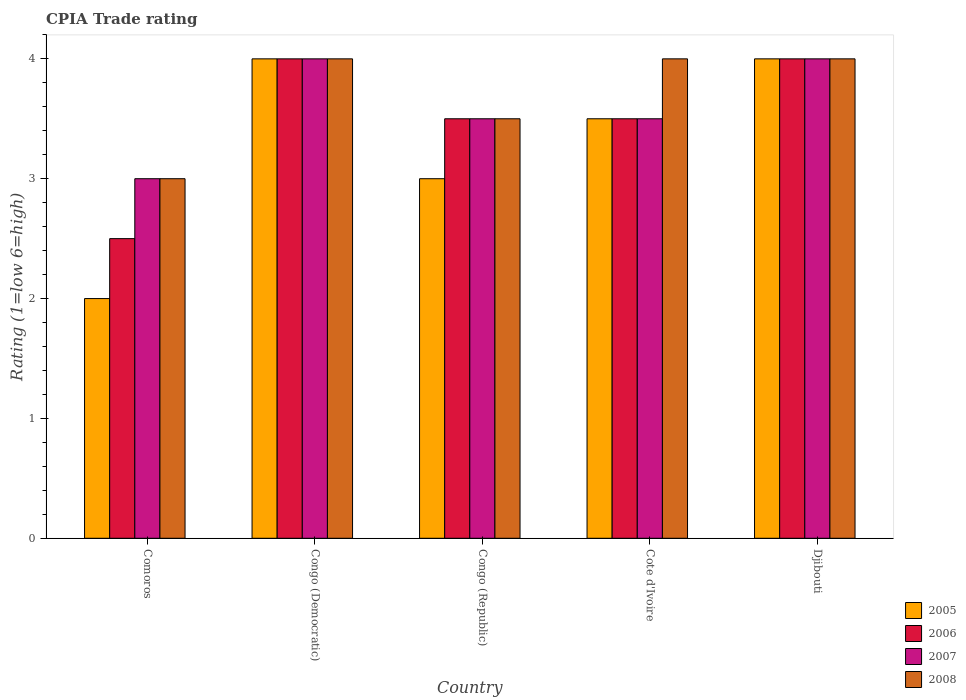Are the number of bars per tick equal to the number of legend labels?
Your answer should be very brief. Yes. What is the label of the 4th group of bars from the left?
Give a very brief answer. Cote d'Ivoire. In how many cases, is the number of bars for a given country not equal to the number of legend labels?
Your response must be concise. 0. In which country was the CPIA rating in 2007 maximum?
Keep it short and to the point. Congo (Democratic). In which country was the CPIA rating in 2006 minimum?
Your answer should be very brief. Comoros. What is the total CPIA rating in 2007 in the graph?
Offer a terse response. 18. What is the difference between the CPIA rating in 2007 in Comoros and that in Congo (Republic)?
Ensure brevity in your answer.  -0.5. What is the difference between the CPIA rating in 2008 in Djibouti and the CPIA rating in 2006 in Congo (Republic)?
Your answer should be very brief. 0.5. What is the ratio of the CPIA rating in 2007 in Comoros to that in Congo (Democratic)?
Ensure brevity in your answer.  0.75. Is the difference between the CPIA rating in 2005 in Congo (Democratic) and Cote d'Ivoire greater than the difference between the CPIA rating in 2008 in Congo (Democratic) and Cote d'Ivoire?
Your answer should be very brief. Yes. What is the difference between the highest and the second highest CPIA rating in 2005?
Ensure brevity in your answer.  -0.5. Is the sum of the CPIA rating in 2005 in Congo (Republic) and Djibouti greater than the maximum CPIA rating in 2006 across all countries?
Ensure brevity in your answer.  Yes. What does the 2nd bar from the right in Congo (Democratic) represents?
Provide a succinct answer. 2007. Is it the case that in every country, the sum of the CPIA rating in 2007 and CPIA rating in 2008 is greater than the CPIA rating in 2006?
Keep it short and to the point. Yes. How many bars are there?
Offer a terse response. 20. How many countries are there in the graph?
Offer a very short reply. 5. What is the difference between two consecutive major ticks on the Y-axis?
Make the answer very short. 1. Does the graph contain any zero values?
Make the answer very short. No. Does the graph contain grids?
Provide a succinct answer. No. How many legend labels are there?
Provide a short and direct response. 4. How are the legend labels stacked?
Offer a very short reply. Vertical. What is the title of the graph?
Ensure brevity in your answer.  CPIA Trade rating. Does "2000" appear as one of the legend labels in the graph?
Provide a short and direct response. No. What is the Rating (1=low 6=high) of 2005 in Comoros?
Offer a very short reply. 2. What is the Rating (1=low 6=high) in 2006 in Comoros?
Give a very brief answer. 2.5. What is the Rating (1=low 6=high) in 2005 in Congo (Democratic)?
Your answer should be very brief. 4. What is the Rating (1=low 6=high) in 2006 in Congo (Democratic)?
Provide a succinct answer. 4. What is the Rating (1=low 6=high) of 2007 in Congo (Democratic)?
Your answer should be very brief. 4. What is the Rating (1=low 6=high) in 2008 in Congo (Democratic)?
Keep it short and to the point. 4. What is the Rating (1=low 6=high) in 2006 in Congo (Republic)?
Keep it short and to the point. 3.5. What is the Rating (1=low 6=high) of 2007 in Congo (Republic)?
Offer a very short reply. 3.5. What is the Rating (1=low 6=high) of 2008 in Congo (Republic)?
Your answer should be very brief. 3.5. What is the Rating (1=low 6=high) in 2005 in Cote d'Ivoire?
Provide a succinct answer. 3.5. What is the Rating (1=low 6=high) in 2005 in Djibouti?
Your answer should be very brief. 4. What is the Rating (1=low 6=high) of 2007 in Djibouti?
Your answer should be very brief. 4. What is the Rating (1=low 6=high) of 2008 in Djibouti?
Provide a short and direct response. 4. Across all countries, what is the maximum Rating (1=low 6=high) in 2005?
Offer a very short reply. 4. Across all countries, what is the maximum Rating (1=low 6=high) in 2006?
Your answer should be compact. 4. Across all countries, what is the minimum Rating (1=low 6=high) of 2007?
Offer a very short reply. 3. What is the total Rating (1=low 6=high) in 2005 in the graph?
Offer a terse response. 16.5. What is the total Rating (1=low 6=high) in 2008 in the graph?
Keep it short and to the point. 18.5. What is the difference between the Rating (1=low 6=high) of 2005 in Comoros and that in Congo (Democratic)?
Provide a short and direct response. -2. What is the difference between the Rating (1=low 6=high) of 2006 in Comoros and that in Congo (Democratic)?
Ensure brevity in your answer.  -1.5. What is the difference between the Rating (1=low 6=high) in 2007 in Comoros and that in Congo (Democratic)?
Your response must be concise. -1. What is the difference between the Rating (1=low 6=high) of 2008 in Comoros and that in Congo (Democratic)?
Offer a very short reply. -1. What is the difference between the Rating (1=low 6=high) of 2005 in Comoros and that in Congo (Republic)?
Provide a short and direct response. -1. What is the difference between the Rating (1=low 6=high) of 2006 in Comoros and that in Congo (Republic)?
Your answer should be compact. -1. What is the difference between the Rating (1=low 6=high) in 2007 in Comoros and that in Congo (Republic)?
Ensure brevity in your answer.  -0.5. What is the difference between the Rating (1=low 6=high) of 2008 in Comoros and that in Congo (Republic)?
Provide a succinct answer. -0.5. What is the difference between the Rating (1=low 6=high) of 2005 in Comoros and that in Cote d'Ivoire?
Offer a terse response. -1.5. What is the difference between the Rating (1=low 6=high) in 2005 in Comoros and that in Djibouti?
Provide a succinct answer. -2. What is the difference between the Rating (1=low 6=high) in 2008 in Congo (Democratic) and that in Congo (Republic)?
Your answer should be compact. 0.5. What is the difference between the Rating (1=low 6=high) of 2006 in Congo (Democratic) and that in Cote d'Ivoire?
Your answer should be compact. 0.5. What is the difference between the Rating (1=low 6=high) in 2007 in Congo (Democratic) and that in Cote d'Ivoire?
Offer a very short reply. 0.5. What is the difference between the Rating (1=low 6=high) of 2008 in Congo (Democratic) and that in Cote d'Ivoire?
Your response must be concise. 0. What is the difference between the Rating (1=low 6=high) in 2005 in Congo (Democratic) and that in Djibouti?
Your answer should be compact. 0. What is the difference between the Rating (1=low 6=high) in 2007 in Congo (Democratic) and that in Djibouti?
Offer a very short reply. 0. What is the difference between the Rating (1=low 6=high) in 2006 in Congo (Republic) and that in Cote d'Ivoire?
Your answer should be compact. 0. What is the difference between the Rating (1=low 6=high) of 2008 in Congo (Republic) and that in Cote d'Ivoire?
Provide a succinct answer. -0.5. What is the difference between the Rating (1=low 6=high) of 2005 in Cote d'Ivoire and that in Djibouti?
Your answer should be compact. -0.5. What is the difference between the Rating (1=low 6=high) of 2006 in Cote d'Ivoire and that in Djibouti?
Ensure brevity in your answer.  -0.5. What is the difference between the Rating (1=low 6=high) in 2008 in Cote d'Ivoire and that in Djibouti?
Provide a succinct answer. 0. What is the difference between the Rating (1=low 6=high) of 2006 in Comoros and the Rating (1=low 6=high) of 2007 in Congo (Democratic)?
Make the answer very short. -1.5. What is the difference between the Rating (1=low 6=high) of 2007 in Comoros and the Rating (1=low 6=high) of 2008 in Congo (Democratic)?
Offer a very short reply. -1. What is the difference between the Rating (1=low 6=high) of 2006 in Comoros and the Rating (1=low 6=high) of 2007 in Congo (Republic)?
Ensure brevity in your answer.  -1. What is the difference between the Rating (1=low 6=high) in 2006 in Comoros and the Rating (1=low 6=high) in 2008 in Congo (Republic)?
Your answer should be very brief. -1. What is the difference between the Rating (1=low 6=high) of 2007 in Comoros and the Rating (1=low 6=high) of 2008 in Congo (Republic)?
Your answer should be compact. -0.5. What is the difference between the Rating (1=low 6=high) in 2005 in Comoros and the Rating (1=low 6=high) in 2006 in Cote d'Ivoire?
Your answer should be compact. -1.5. What is the difference between the Rating (1=low 6=high) in 2005 in Comoros and the Rating (1=low 6=high) in 2006 in Djibouti?
Keep it short and to the point. -2. What is the difference between the Rating (1=low 6=high) of 2005 in Comoros and the Rating (1=low 6=high) of 2008 in Djibouti?
Offer a terse response. -2. What is the difference between the Rating (1=low 6=high) in 2006 in Comoros and the Rating (1=low 6=high) in 2007 in Djibouti?
Make the answer very short. -1.5. What is the difference between the Rating (1=low 6=high) of 2006 in Comoros and the Rating (1=low 6=high) of 2008 in Djibouti?
Your answer should be compact. -1.5. What is the difference between the Rating (1=low 6=high) of 2006 in Congo (Democratic) and the Rating (1=low 6=high) of 2007 in Congo (Republic)?
Offer a terse response. 0.5. What is the difference between the Rating (1=low 6=high) of 2006 in Congo (Democratic) and the Rating (1=low 6=high) of 2008 in Congo (Republic)?
Your answer should be very brief. 0.5. What is the difference between the Rating (1=low 6=high) of 2007 in Congo (Democratic) and the Rating (1=low 6=high) of 2008 in Congo (Republic)?
Provide a short and direct response. 0.5. What is the difference between the Rating (1=low 6=high) of 2005 in Congo (Democratic) and the Rating (1=low 6=high) of 2007 in Cote d'Ivoire?
Offer a terse response. 0.5. What is the difference between the Rating (1=low 6=high) of 2006 in Congo (Democratic) and the Rating (1=low 6=high) of 2007 in Cote d'Ivoire?
Give a very brief answer. 0.5. What is the difference between the Rating (1=low 6=high) of 2006 in Congo (Democratic) and the Rating (1=low 6=high) of 2008 in Cote d'Ivoire?
Give a very brief answer. 0. What is the difference between the Rating (1=low 6=high) of 2005 in Congo (Democratic) and the Rating (1=low 6=high) of 2007 in Djibouti?
Keep it short and to the point. 0. What is the difference between the Rating (1=low 6=high) in 2005 in Congo (Republic) and the Rating (1=low 6=high) in 2006 in Cote d'Ivoire?
Ensure brevity in your answer.  -0.5. What is the difference between the Rating (1=low 6=high) in 2005 in Congo (Republic) and the Rating (1=low 6=high) in 2007 in Cote d'Ivoire?
Give a very brief answer. -0.5. What is the difference between the Rating (1=low 6=high) in 2005 in Congo (Republic) and the Rating (1=low 6=high) in 2008 in Cote d'Ivoire?
Make the answer very short. -1. What is the difference between the Rating (1=low 6=high) in 2006 in Congo (Republic) and the Rating (1=low 6=high) in 2008 in Cote d'Ivoire?
Offer a very short reply. -0.5. What is the difference between the Rating (1=low 6=high) of 2007 in Congo (Republic) and the Rating (1=low 6=high) of 2008 in Cote d'Ivoire?
Your response must be concise. -0.5. What is the difference between the Rating (1=low 6=high) of 2005 in Congo (Republic) and the Rating (1=low 6=high) of 2007 in Djibouti?
Provide a short and direct response. -1. What is the difference between the Rating (1=low 6=high) of 2005 in Congo (Republic) and the Rating (1=low 6=high) of 2008 in Djibouti?
Provide a succinct answer. -1. What is the difference between the Rating (1=low 6=high) of 2006 in Congo (Republic) and the Rating (1=low 6=high) of 2007 in Djibouti?
Offer a terse response. -0.5. What is the difference between the Rating (1=low 6=high) of 2007 in Congo (Republic) and the Rating (1=low 6=high) of 2008 in Djibouti?
Make the answer very short. -0.5. What is the difference between the Rating (1=low 6=high) in 2005 in Cote d'Ivoire and the Rating (1=low 6=high) in 2007 in Djibouti?
Ensure brevity in your answer.  -0.5. What is the difference between the Rating (1=low 6=high) in 2007 in Cote d'Ivoire and the Rating (1=low 6=high) in 2008 in Djibouti?
Your answer should be very brief. -0.5. What is the average Rating (1=low 6=high) in 2005 per country?
Your answer should be very brief. 3.3. What is the average Rating (1=low 6=high) of 2006 per country?
Offer a terse response. 3.5. What is the average Rating (1=low 6=high) of 2007 per country?
Your answer should be compact. 3.6. What is the difference between the Rating (1=low 6=high) in 2005 and Rating (1=low 6=high) in 2006 in Comoros?
Offer a terse response. -0.5. What is the difference between the Rating (1=low 6=high) of 2005 and Rating (1=low 6=high) of 2007 in Comoros?
Keep it short and to the point. -1. What is the difference between the Rating (1=low 6=high) of 2007 and Rating (1=low 6=high) of 2008 in Comoros?
Offer a very short reply. 0. What is the difference between the Rating (1=low 6=high) of 2005 and Rating (1=low 6=high) of 2006 in Congo (Democratic)?
Give a very brief answer. 0. What is the difference between the Rating (1=low 6=high) in 2005 and Rating (1=low 6=high) in 2007 in Congo (Democratic)?
Offer a very short reply. 0. What is the difference between the Rating (1=low 6=high) of 2005 and Rating (1=low 6=high) of 2008 in Congo (Democratic)?
Keep it short and to the point. 0. What is the difference between the Rating (1=low 6=high) of 2006 and Rating (1=low 6=high) of 2008 in Congo (Republic)?
Provide a short and direct response. 0. What is the difference between the Rating (1=low 6=high) of 2007 and Rating (1=low 6=high) of 2008 in Congo (Republic)?
Provide a short and direct response. 0. What is the difference between the Rating (1=low 6=high) of 2005 and Rating (1=low 6=high) of 2007 in Cote d'Ivoire?
Make the answer very short. 0. What is the difference between the Rating (1=low 6=high) of 2006 and Rating (1=low 6=high) of 2007 in Cote d'Ivoire?
Offer a terse response. 0. What is the difference between the Rating (1=low 6=high) in 2006 and Rating (1=low 6=high) in 2008 in Cote d'Ivoire?
Your answer should be compact. -0.5. What is the difference between the Rating (1=low 6=high) of 2005 and Rating (1=low 6=high) of 2006 in Djibouti?
Offer a terse response. 0. What is the difference between the Rating (1=low 6=high) in 2006 and Rating (1=low 6=high) in 2007 in Djibouti?
Offer a very short reply. 0. What is the difference between the Rating (1=low 6=high) in 2007 and Rating (1=low 6=high) in 2008 in Djibouti?
Ensure brevity in your answer.  0. What is the ratio of the Rating (1=low 6=high) of 2006 in Comoros to that in Congo (Democratic)?
Provide a short and direct response. 0.62. What is the ratio of the Rating (1=low 6=high) in 2007 in Comoros to that in Congo (Democratic)?
Offer a terse response. 0.75. What is the ratio of the Rating (1=low 6=high) of 2005 in Comoros to that in Congo (Republic)?
Your answer should be compact. 0.67. What is the ratio of the Rating (1=low 6=high) of 2006 in Comoros to that in Congo (Republic)?
Offer a terse response. 0.71. What is the ratio of the Rating (1=low 6=high) of 2005 in Comoros to that in Cote d'Ivoire?
Your answer should be very brief. 0.57. What is the ratio of the Rating (1=low 6=high) of 2007 in Comoros to that in Cote d'Ivoire?
Your answer should be very brief. 0.86. What is the ratio of the Rating (1=low 6=high) of 2008 in Comoros to that in Cote d'Ivoire?
Your answer should be very brief. 0.75. What is the ratio of the Rating (1=low 6=high) in 2007 in Comoros to that in Djibouti?
Provide a succinct answer. 0.75. What is the ratio of the Rating (1=low 6=high) of 2008 in Comoros to that in Djibouti?
Your response must be concise. 0.75. What is the ratio of the Rating (1=low 6=high) of 2008 in Congo (Democratic) to that in Congo (Republic)?
Your answer should be very brief. 1.14. What is the ratio of the Rating (1=low 6=high) in 2005 in Congo (Democratic) to that in Cote d'Ivoire?
Keep it short and to the point. 1.14. What is the ratio of the Rating (1=low 6=high) in 2008 in Congo (Democratic) to that in Cote d'Ivoire?
Provide a short and direct response. 1. What is the ratio of the Rating (1=low 6=high) in 2005 in Congo (Democratic) to that in Djibouti?
Your answer should be very brief. 1. What is the ratio of the Rating (1=low 6=high) in 2006 in Congo (Democratic) to that in Djibouti?
Offer a very short reply. 1. What is the ratio of the Rating (1=low 6=high) in 2007 in Congo (Democratic) to that in Djibouti?
Ensure brevity in your answer.  1. What is the ratio of the Rating (1=low 6=high) in 2007 in Congo (Republic) to that in Cote d'Ivoire?
Your answer should be very brief. 1. What is the ratio of the Rating (1=low 6=high) of 2008 in Congo (Republic) to that in Cote d'Ivoire?
Your answer should be compact. 0.88. What is the ratio of the Rating (1=low 6=high) of 2005 in Congo (Republic) to that in Djibouti?
Make the answer very short. 0.75. What is the ratio of the Rating (1=low 6=high) in 2006 in Congo (Republic) to that in Djibouti?
Provide a short and direct response. 0.88. What is the ratio of the Rating (1=low 6=high) in 2007 in Congo (Republic) to that in Djibouti?
Make the answer very short. 0.88. What is the ratio of the Rating (1=low 6=high) in 2005 in Cote d'Ivoire to that in Djibouti?
Your response must be concise. 0.88. What is the ratio of the Rating (1=low 6=high) of 2006 in Cote d'Ivoire to that in Djibouti?
Offer a very short reply. 0.88. What is the ratio of the Rating (1=low 6=high) of 2008 in Cote d'Ivoire to that in Djibouti?
Ensure brevity in your answer.  1. What is the difference between the highest and the second highest Rating (1=low 6=high) in 2006?
Ensure brevity in your answer.  0. What is the difference between the highest and the second highest Rating (1=low 6=high) of 2008?
Make the answer very short. 0. What is the difference between the highest and the lowest Rating (1=low 6=high) of 2005?
Offer a very short reply. 2. What is the difference between the highest and the lowest Rating (1=low 6=high) of 2007?
Keep it short and to the point. 1. 